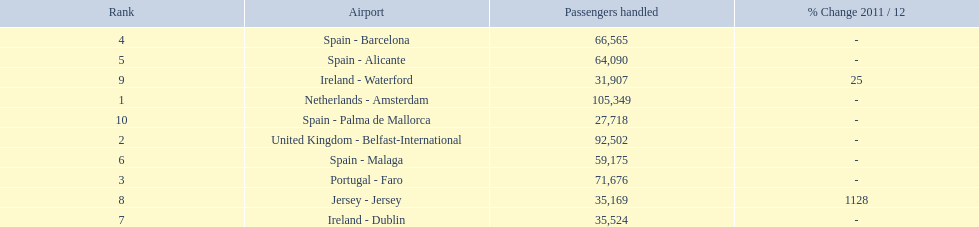Name all the london southend airports that did not list a change in 2001/12. Netherlands - Amsterdam, United Kingdom - Belfast-International, Portugal - Faro, Spain - Barcelona, Spain - Alicante, Spain - Malaga, Ireland - Dublin, Spain - Palma de Mallorca. What unchanged percentage airports from 2011/12 handled less then 50,000 passengers? Ireland - Dublin, Spain - Palma de Mallorca. What unchanged percentage airport from 2011/12 handled less then 50,000 passengers is the closest to the equator? Spain - Palma de Mallorca. 